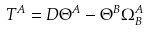<formula> <loc_0><loc_0><loc_500><loc_500>T ^ { A } = D \Theta ^ { A } - \Theta ^ { B } \Omega _ { B } ^ { A }</formula> 